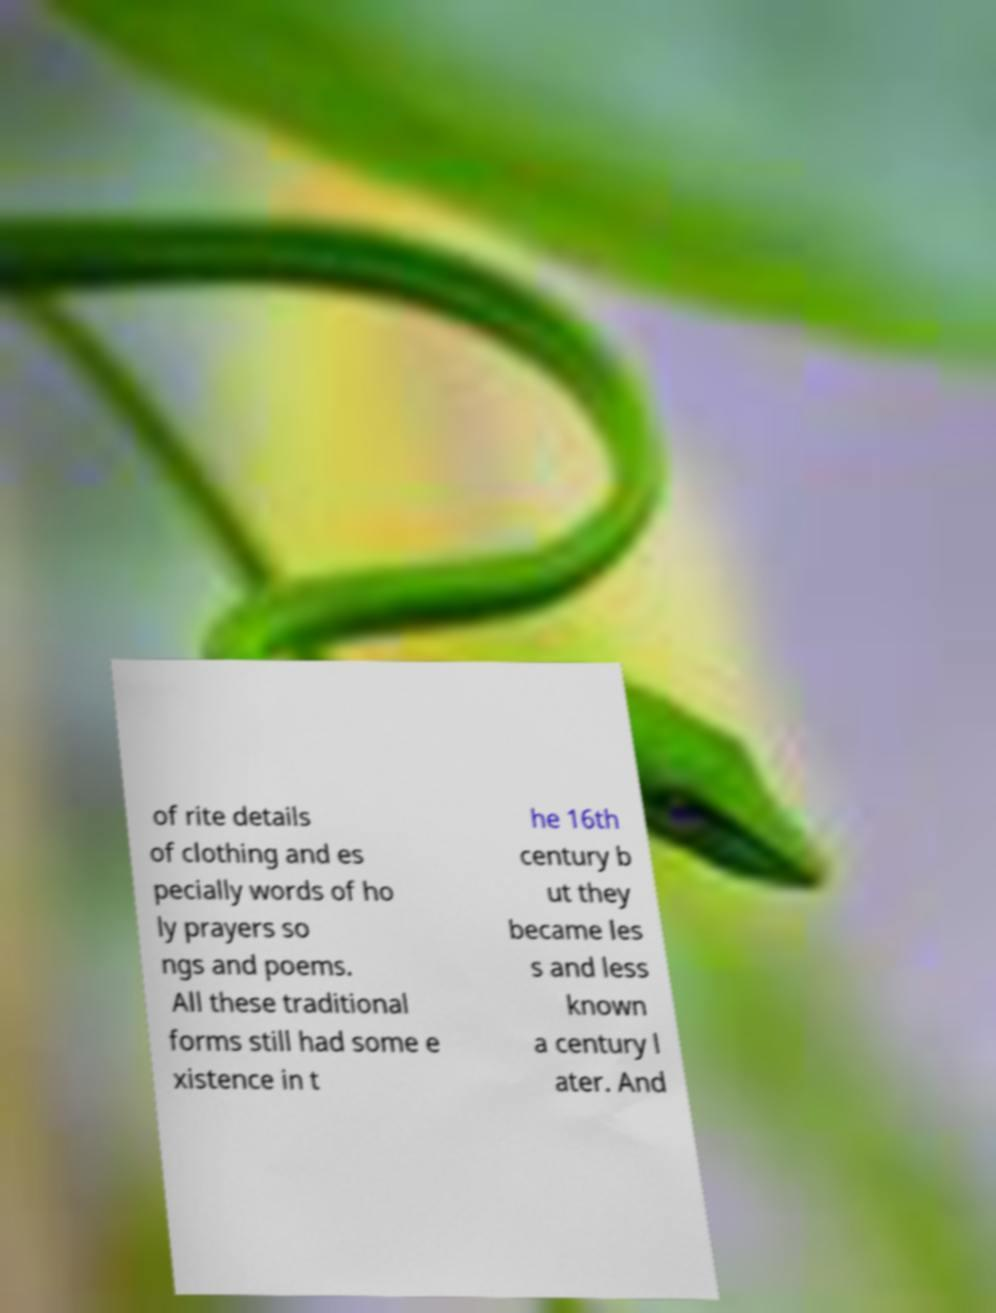Can you read and provide the text displayed in the image?This photo seems to have some interesting text. Can you extract and type it out for me? of rite details of clothing and es pecially words of ho ly prayers so ngs and poems. All these traditional forms still had some e xistence in t he 16th century b ut they became les s and less known a century l ater. And 